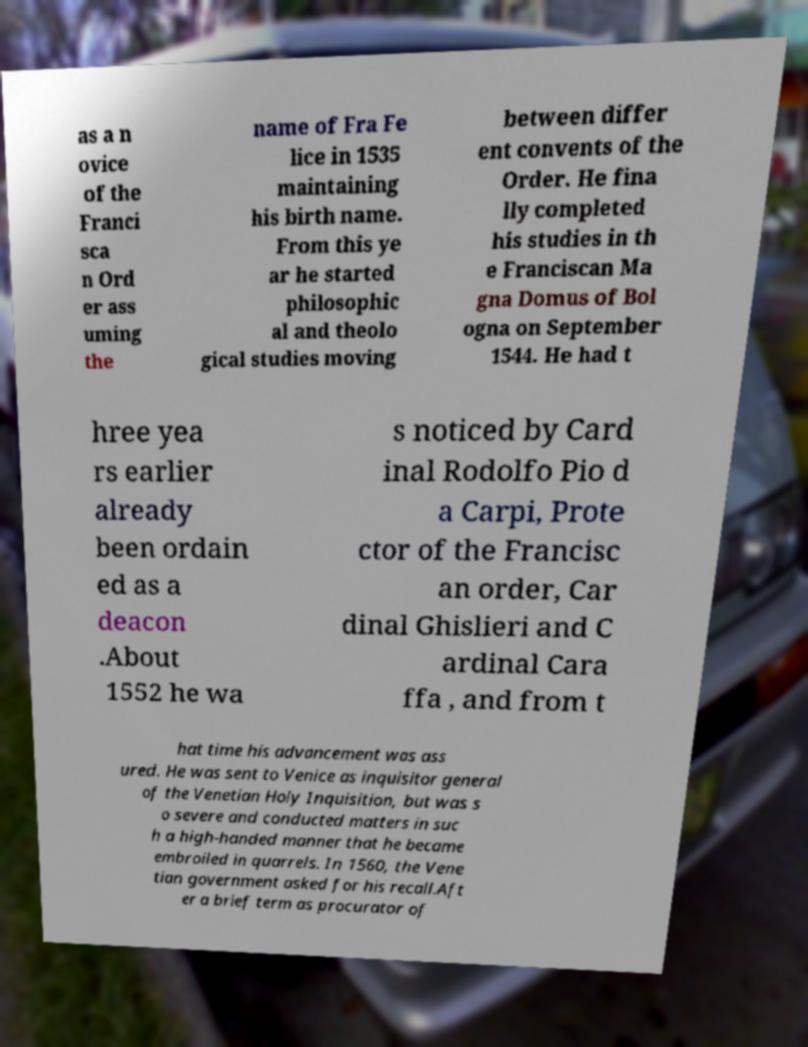Please read and relay the text visible in this image. What does it say? as a n ovice of the Franci sca n Ord er ass uming the name of Fra Fe lice in 1535 maintaining his birth name. From this ye ar he started philosophic al and theolo gical studies moving between differ ent convents of the Order. He fina lly completed his studies in th e Franciscan Ma gna Domus of Bol ogna on September 1544. He had t hree yea rs earlier already been ordain ed as a deacon .About 1552 he wa s noticed by Card inal Rodolfo Pio d a Carpi, Prote ctor of the Francisc an order, Car dinal Ghislieri and C ardinal Cara ffa , and from t hat time his advancement was ass ured. He was sent to Venice as inquisitor general of the Venetian Holy Inquisition, but was s o severe and conducted matters in suc h a high-handed manner that he became embroiled in quarrels. In 1560, the Vene tian government asked for his recall.Aft er a brief term as procurator of 